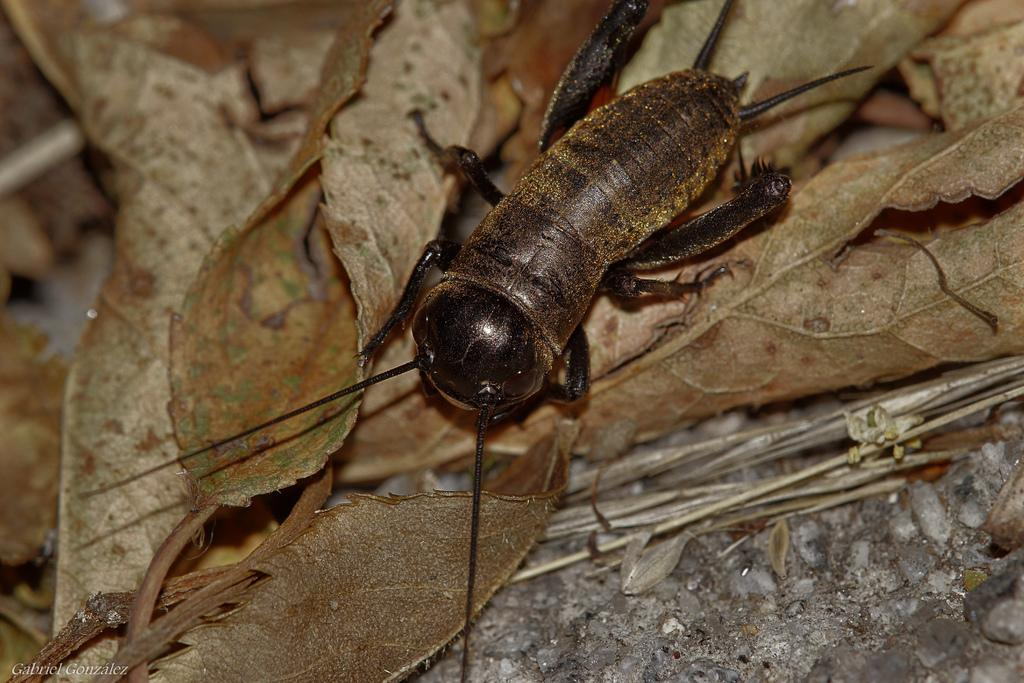What type of creature can be seen in the image? There is an insect in the image. Where is the insect located? The insect is on leaves in the image. What other objects can be seen in the image? There are small stones and sticks in the image. How does the insect aid in the digestion of the goose in the image? There is no goose present in the image, and the insect is not shown interacting with any creature. 